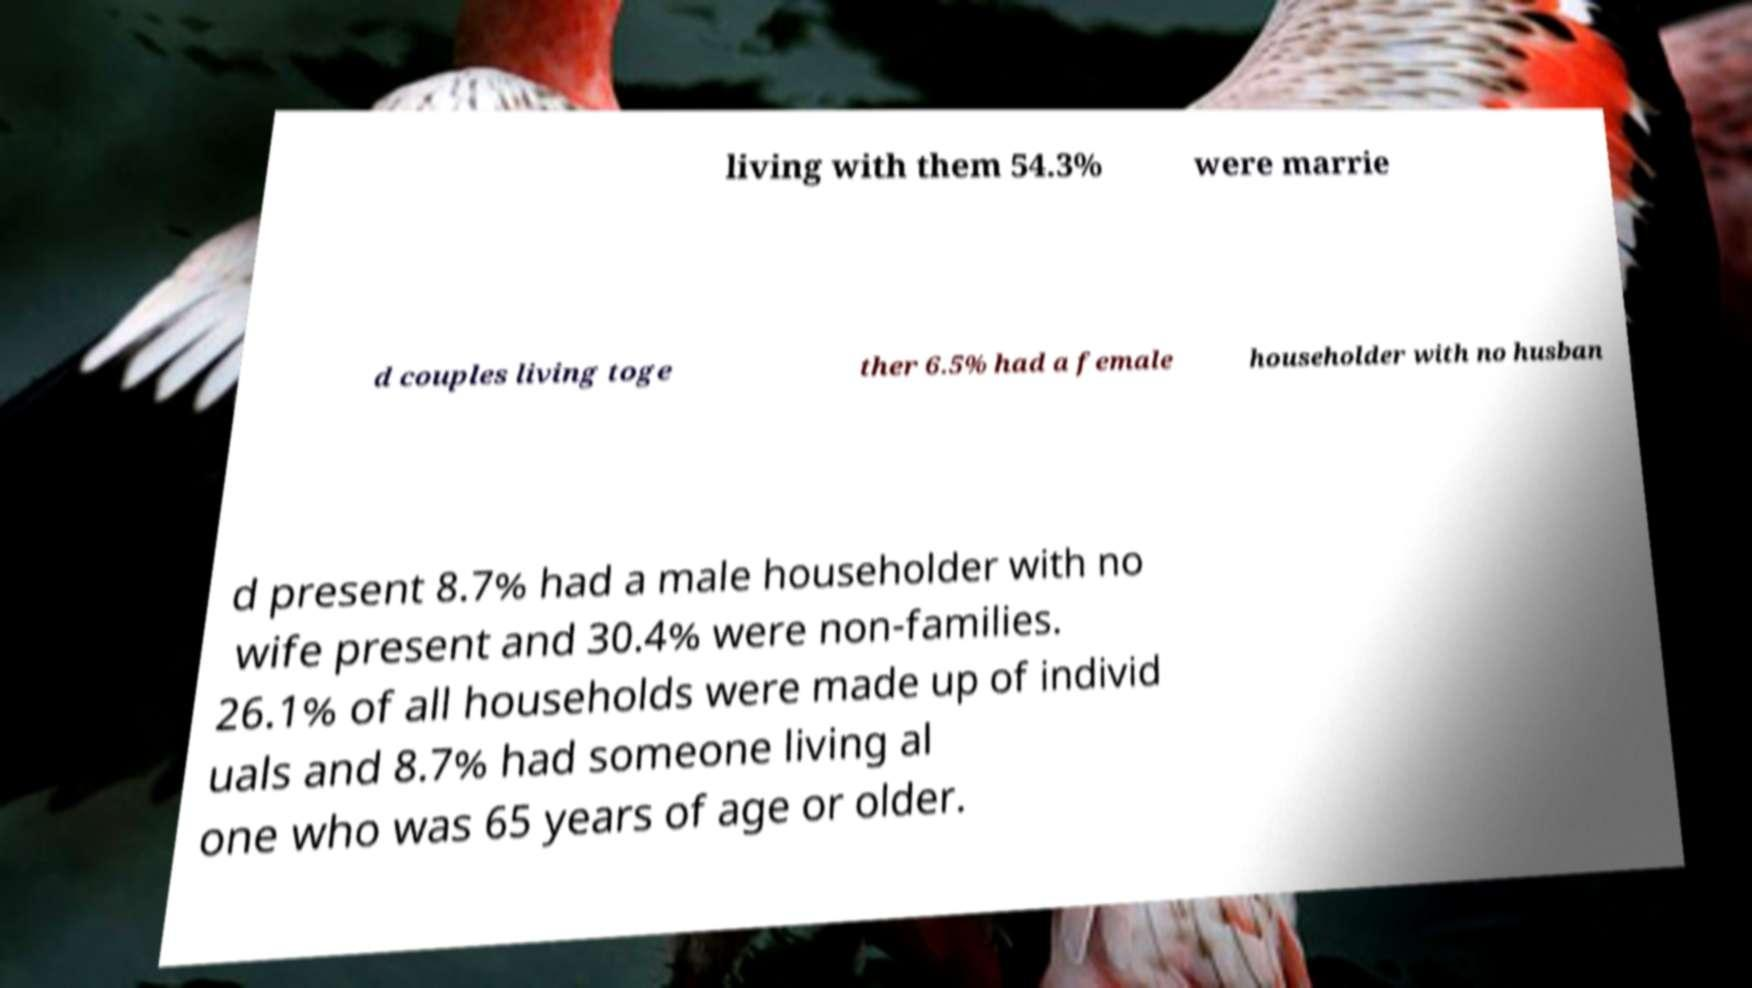Please read and relay the text visible in this image. What does it say? living with them 54.3% were marrie d couples living toge ther 6.5% had a female householder with no husban d present 8.7% had a male householder with no wife present and 30.4% were non-families. 26.1% of all households were made up of individ uals and 8.7% had someone living al one who was 65 years of age or older. 